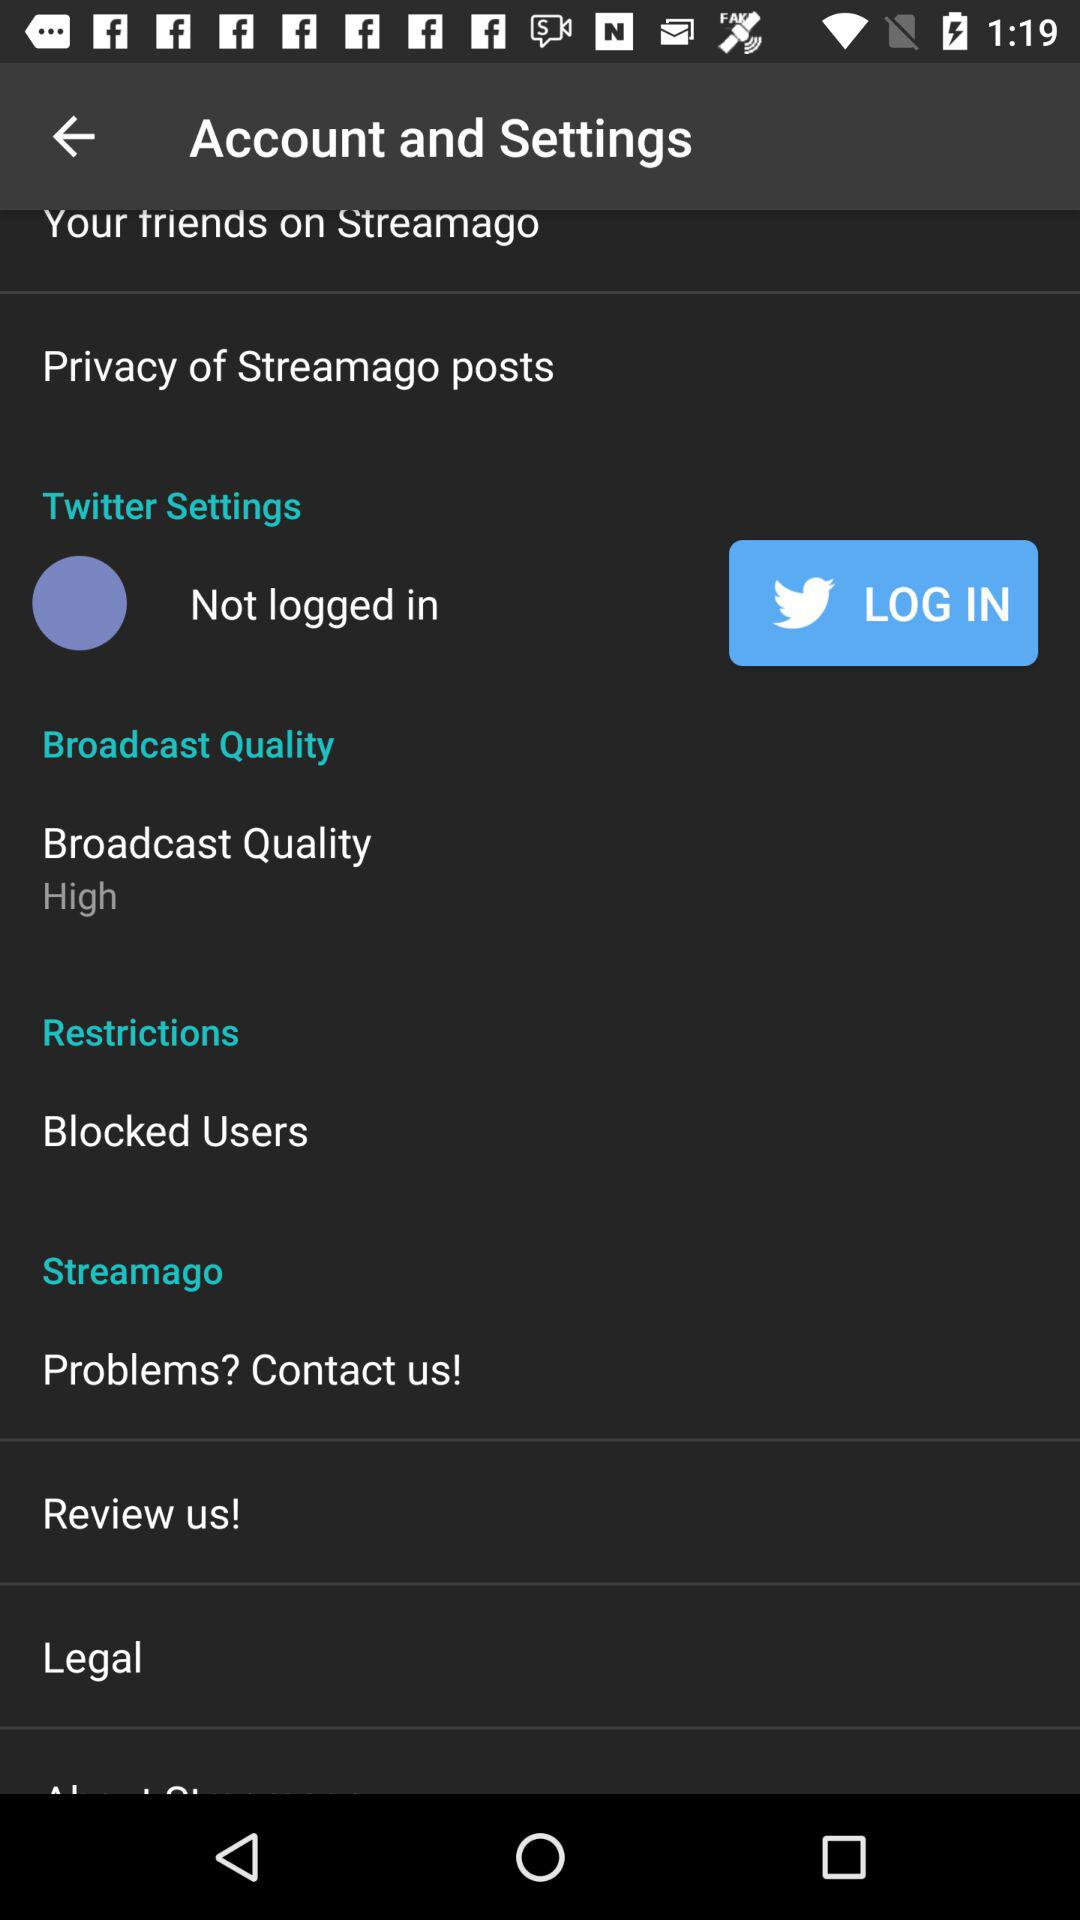What is the selected broadcast quality? The selected broadcast quality is "High". 